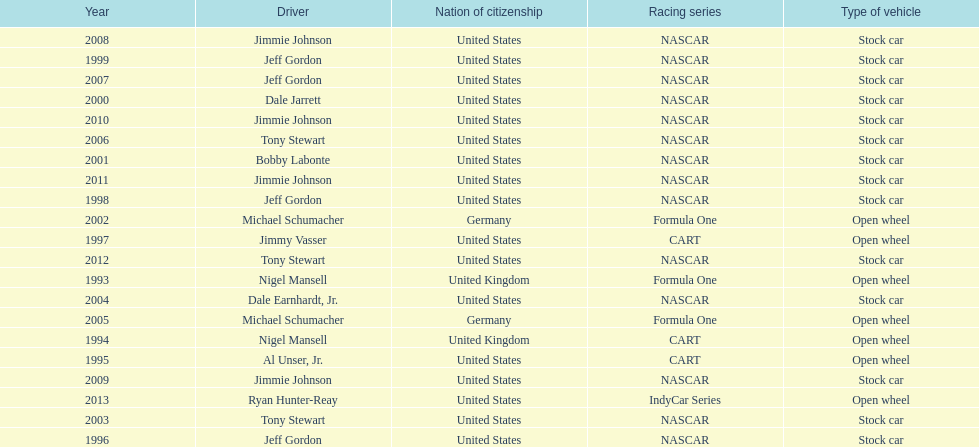Out of these drivers: nigel mansell, al unser, jr., michael schumacher, and jeff gordon, all but one has more than one espy award. who only has one espy award? Al Unser, Jr. 